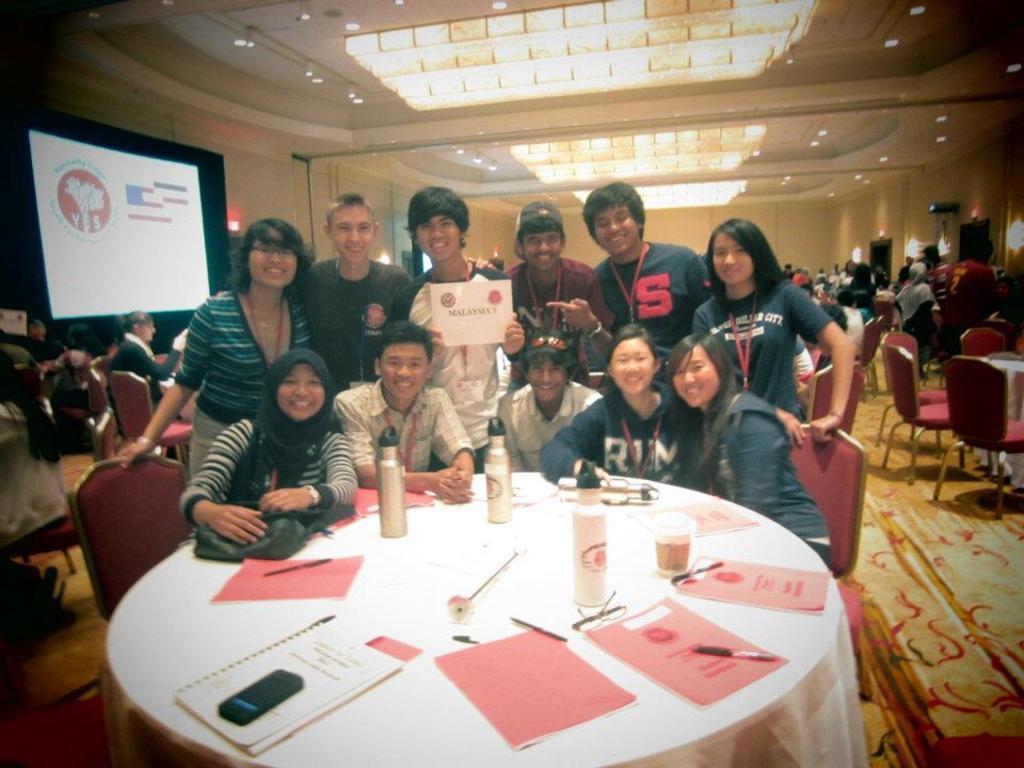Can you describe this image briefly? This picture is taken inside a room. there are many people in the room. There are tables and chairs. There is also a carpet in the room. There are many lights to the ceiling. In the left corner there is big screen and a logo and text is displayed on it. On the table there are books, bottles, glasses spectacles, mobile phones and pens. The people at the table are posing for a picture and smiling. The man standing in the center is holding a certificate.  